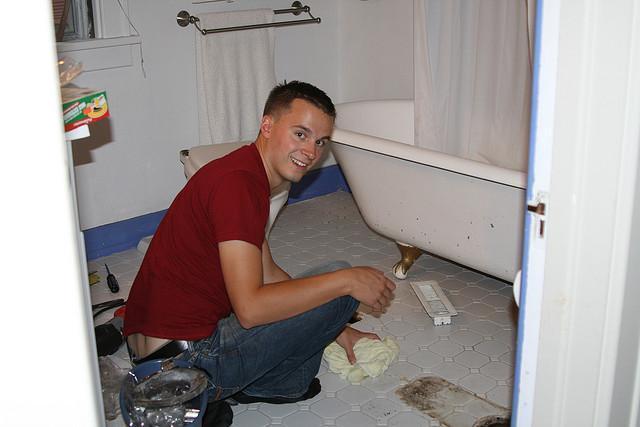How many towels are hanging on the towel rack?
Give a very brief answer. 1. 